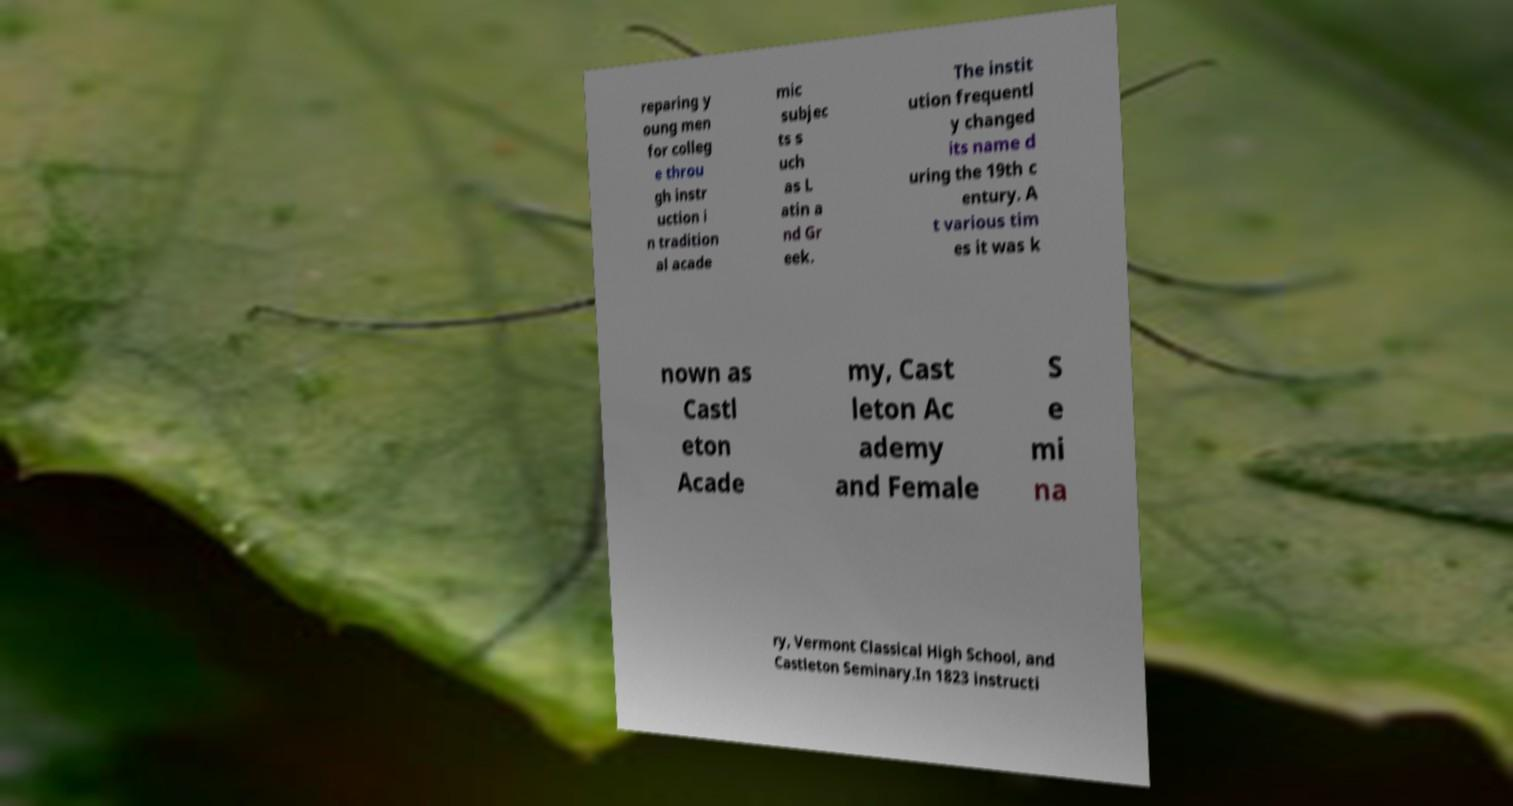Could you assist in decoding the text presented in this image and type it out clearly? reparing y oung men for colleg e throu gh instr uction i n tradition al acade mic subjec ts s uch as L atin a nd Gr eek. The instit ution frequentl y changed its name d uring the 19th c entury. A t various tim es it was k nown as Castl eton Acade my, Cast leton Ac ademy and Female S e mi na ry, Vermont Classical High School, and Castleton Seminary.In 1823 instructi 